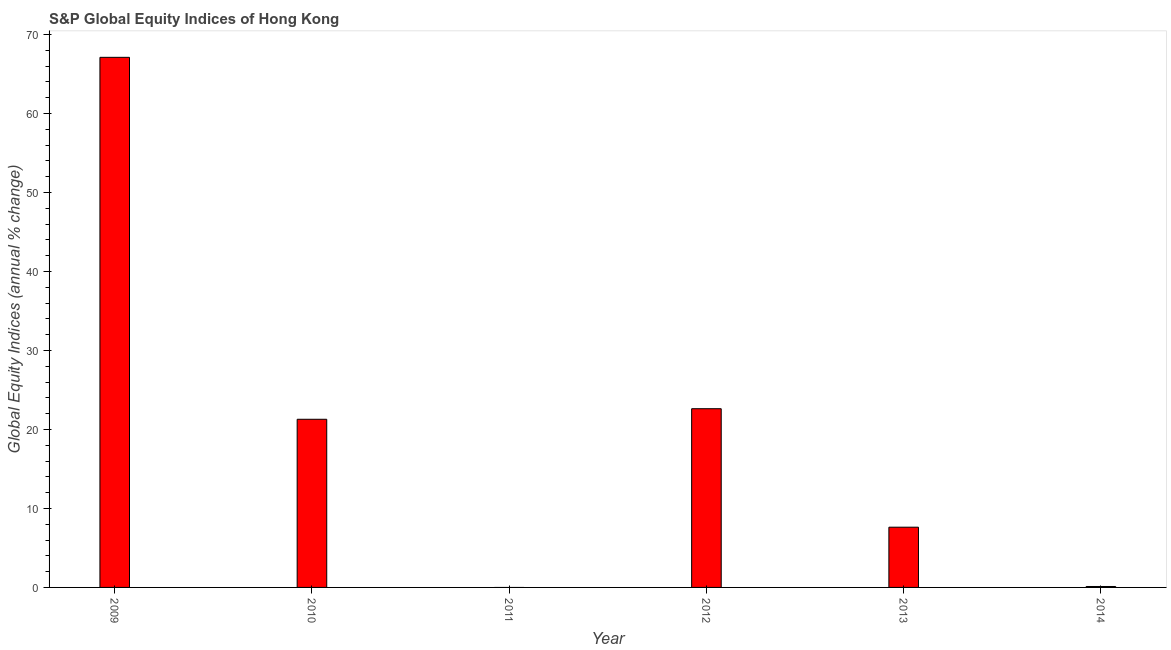Does the graph contain grids?
Your response must be concise. No. What is the title of the graph?
Your response must be concise. S&P Global Equity Indices of Hong Kong. What is the label or title of the Y-axis?
Your answer should be compact. Global Equity Indices (annual % change). What is the s&p global equity indices in 2013?
Your answer should be very brief. 7.62. Across all years, what is the maximum s&p global equity indices?
Ensure brevity in your answer.  67.1. Across all years, what is the minimum s&p global equity indices?
Provide a succinct answer. 0. In which year was the s&p global equity indices maximum?
Give a very brief answer. 2009. What is the sum of the s&p global equity indices?
Your answer should be very brief. 118.76. What is the difference between the s&p global equity indices in 2009 and 2010?
Your response must be concise. 45.82. What is the average s&p global equity indices per year?
Ensure brevity in your answer.  19.79. What is the median s&p global equity indices?
Your answer should be compact. 14.46. In how many years, is the s&p global equity indices greater than 64 %?
Your answer should be very brief. 1. What is the ratio of the s&p global equity indices in 2009 to that in 2014?
Offer a very short reply. 571.85. Is the s&p global equity indices in 2009 less than that in 2012?
Give a very brief answer. No. What is the difference between the highest and the second highest s&p global equity indices?
Make the answer very short. 44.48. Is the sum of the s&p global equity indices in 2009 and 2010 greater than the maximum s&p global equity indices across all years?
Offer a terse response. Yes. What is the difference between the highest and the lowest s&p global equity indices?
Make the answer very short. 67.1. What is the Global Equity Indices (annual % change) in 2009?
Your answer should be very brief. 67.1. What is the Global Equity Indices (annual % change) of 2010?
Provide a succinct answer. 21.29. What is the Global Equity Indices (annual % change) in 2011?
Your answer should be compact. 0. What is the Global Equity Indices (annual % change) in 2012?
Make the answer very short. 22.62. What is the Global Equity Indices (annual % change) of 2013?
Your answer should be compact. 7.62. What is the Global Equity Indices (annual % change) of 2014?
Offer a terse response. 0.12. What is the difference between the Global Equity Indices (annual % change) in 2009 and 2010?
Your answer should be compact. 45.82. What is the difference between the Global Equity Indices (annual % change) in 2009 and 2012?
Provide a succinct answer. 44.48. What is the difference between the Global Equity Indices (annual % change) in 2009 and 2013?
Give a very brief answer. 59.48. What is the difference between the Global Equity Indices (annual % change) in 2009 and 2014?
Keep it short and to the point. 66.99. What is the difference between the Global Equity Indices (annual % change) in 2010 and 2012?
Provide a succinct answer. -1.34. What is the difference between the Global Equity Indices (annual % change) in 2010 and 2013?
Offer a very short reply. 13.66. What is the difference between the Global Equity Indices (annual % change) in 2010 and 2014?
Keep it short and to the point. 21.17. What is the difference between the Global Equity Indices (annual % change) in 2012 and 2013?
Ensure brevity in your answer.  15. What is the difference between the Global Equity Indices (annual % change) in 2012 and 2014?
Offer a very short reply. 22.51. What is the difference between the Global Equity Indices (annual % change) in 2013 and 2014?
Your answer should be very brief. 7.51. What is the ratio of the Global Equity Indices (annual % change) in 2009 to that in 2010?
Your response must be concise. 3.15. What is the ratio of the Global Equity Indices (annual % change) in 2009 to that in 2012?
Your answer should be very brief. 2.97. What is the ratio of the Global Equity Indices (annual % change) in 2009 to that in 2013?
Keep it short and to the point. 8.8. What is the ratio of the Global Equity Indices (annual % change) in 2009 to that in 2014?
Your response must be concise. 571.85. What is the ratio of the Global Equity Indices (annual % change) in 2010 to that in 2012?
Provide a succinct answer. 0.94. What is the ratio of the Global Equity Indices (annual % change) in 2010 to that in 2013?
Give a very brief answer. 2.79. What is the ratio of the Global Equity Indices (annual % change) in 2010 to that in 2014?
Give a very brief answer. 181.4. What is the ratio of the Global Equity Indices (annual % change) in 2012 to that in 2013?
Your answer should be compact. 2.97. What is the ratio of the Global Equity Indices (annual % change) in 2012 to that in 2014?
Offer a very short reply. 192.8. What is the ratio of the Global Equity Indices (annual % change) in 2013 to that in 2014?
Ensure brevity in your answer.  64.98. 